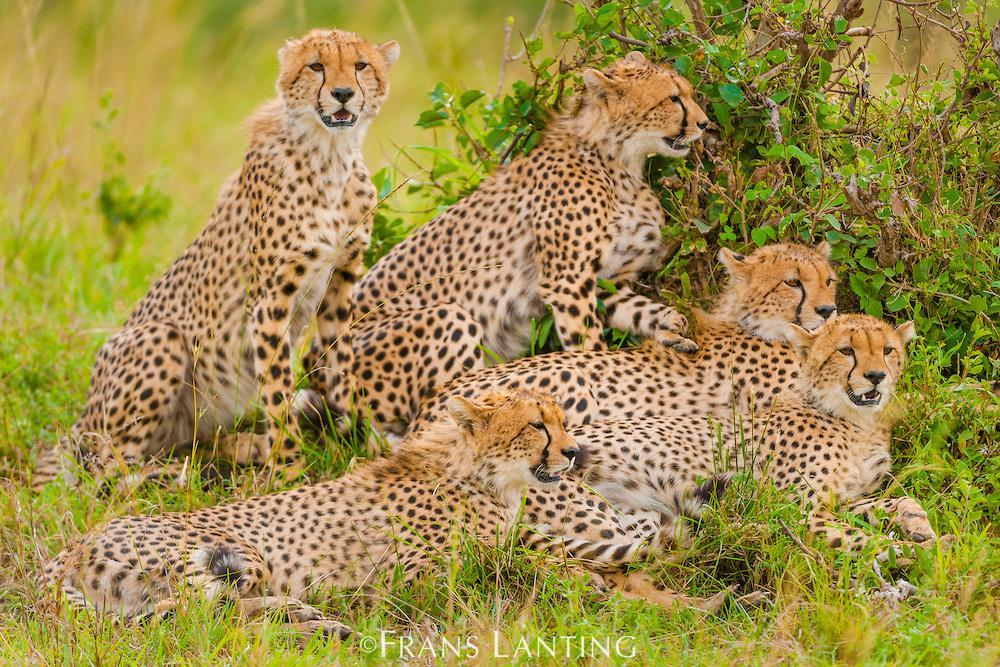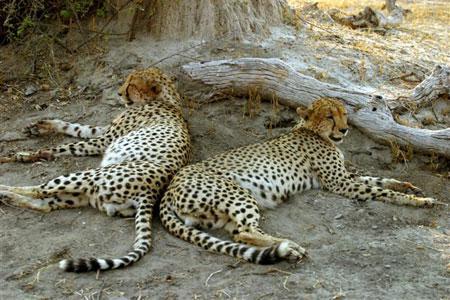The first image is the image on the left, the second image is the image on the right. Given the left and right images, does the statement "There is exactly two cheetahs in the left image." hold true? Answer yes or no. No. The first image is the image on the left, the second image is the image on the right. For the images displayed, is the sentence "One mother and her cub are sitting in the grass together." factually correct? Answer yes or no. No. 